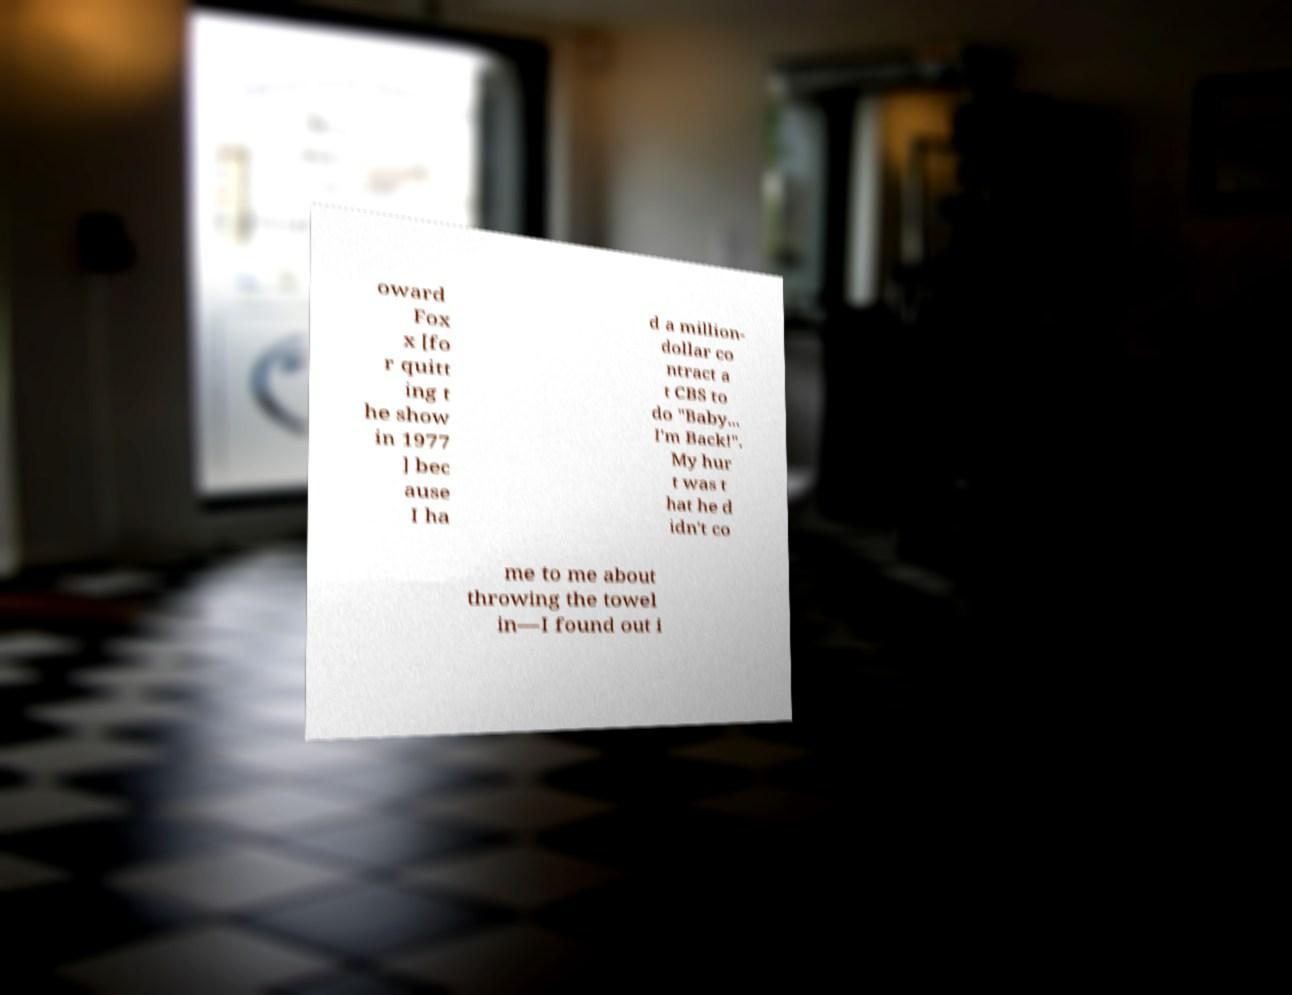I need the written content from this picture converted into text. Can you do that? oward Fox x [fo r quitt ing t he show in 1977 ] bec ause I ha d a million- dollar co ntract a t CBS to do "Baby... I'm Back!". My hur t was t hat he d idn't co me to me about throwing the towel in—I found out i 